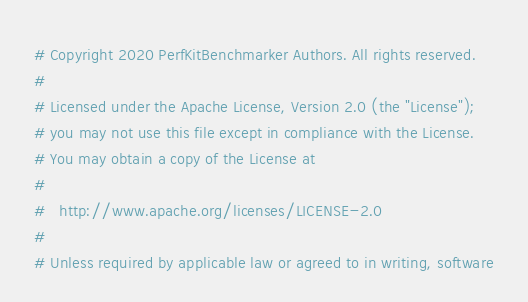Convert code to text. <code><loc_0><loc_0><loc_500><loc_500><_Python_># Copyright 2020 PerfKitBenchmarker Authors. All rights reserved.
#
# Licensed under the Apache License, Version 2.0 (the "License");
# you may not use this file except in compliance with the License.
# You may obtain a copy of the License at
#
#   http://www.apache.org/licenses/LICENSE-2.0
#
# Unless required by applicable law or agreed to in writing, software</code> 